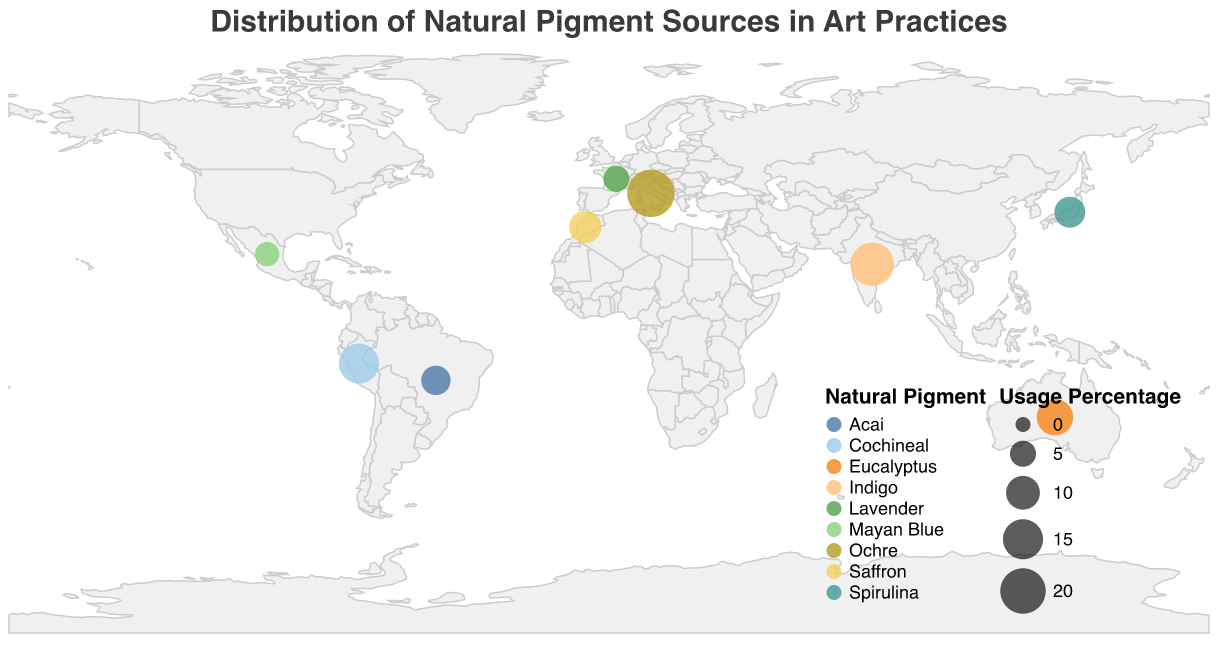What is the title of the figure? The title of the figure is usually placed at the top and is prominently displayed. In this case, the title is "Distribution of Natural Pigment Sources in Art Practices."
Answer: Distribution of Natural Pigment Sources in Art Practices Which country uses Ochre predominantly? By looking at the geographic plot, we can pinpoint Italy as the country associated with Ochre, also highlighted in the data entry.
Answer: Italy What is the primary application of Cochineal? The tooltip for Peru indicates that the primary application of Cochineal is "Vibrant accents," where details such as this are visible.
Answer: Vibrant accents Which country has the highest percentage of natural pigment usage, and what is the pigment? From the plot, the largest circle represents Italy with the highest usage percentage of 22%, and the pigment is Ochre.
Answer: Italy, Ochre How many countries are represented in the figure? By counting the unique entries in the plot or the data provided, we find there are nine countries represented.
Answer: 9 What is the primary application of pigments in India, and what percentage of usage does it hold? India's tool-tip data indicate the use of Indigo primarily for "Textural layering" and a usage percentage of 18%.
Answer: Textural layering, 18% Which countries use pigments primarily for creating organic textures? By examining the figure, Australia with Eucalyptus is stated to use pigments mostly for "Organic textures."
Answer: Australia Compare the usage percentages of Indigo and Spirulina pigments. Indigo has a usage percentage of 18%, whereas Spirulina has 8%. We compare these values to see that Indigo's usage is greater.
Answer: Indigo is higher Which natural pigment is used for "Ethereal highlights," and which country does it come from? Referring to the tooltip data, Mayan Blue is used for "Ethereal highlights" and is from Mexico.
Answer: Mayan Blue, Mexico What is the combined usage percentage of the top three pigments? The top three pigments and their usage percentages are Ochre (22%), Indigo (18%), and Cochineal (15%). Adding these together: 22 + 18 + 15 = 55.
Answer: 55% 